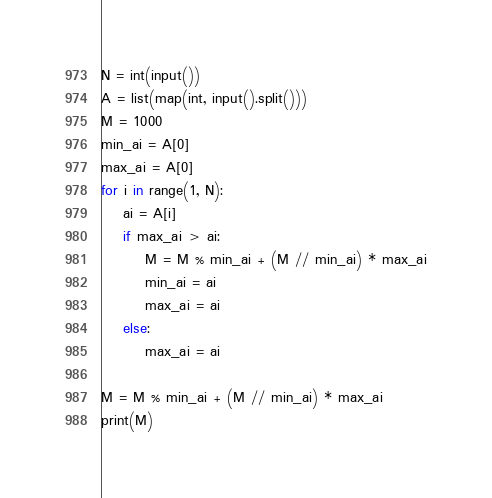Convert code to text. <code><loc_0><loc_0><loc_500><loc_500><_Python_>N = int(input())
A = list(map(int, input().split()))
M = 1000
min_ai = A[0]
max_ai = A[0]
for i in range(1, N):
    ai = A[i]
    if max_ai > ai:
        M = M % min_ai + (M // min_ai) * max_ai
        min_ai = ai
        max_ai = ai
    else:
        max_ai = ai

M = M % min_ai + (M // min_ai) * max_ai
print(M)</code> 